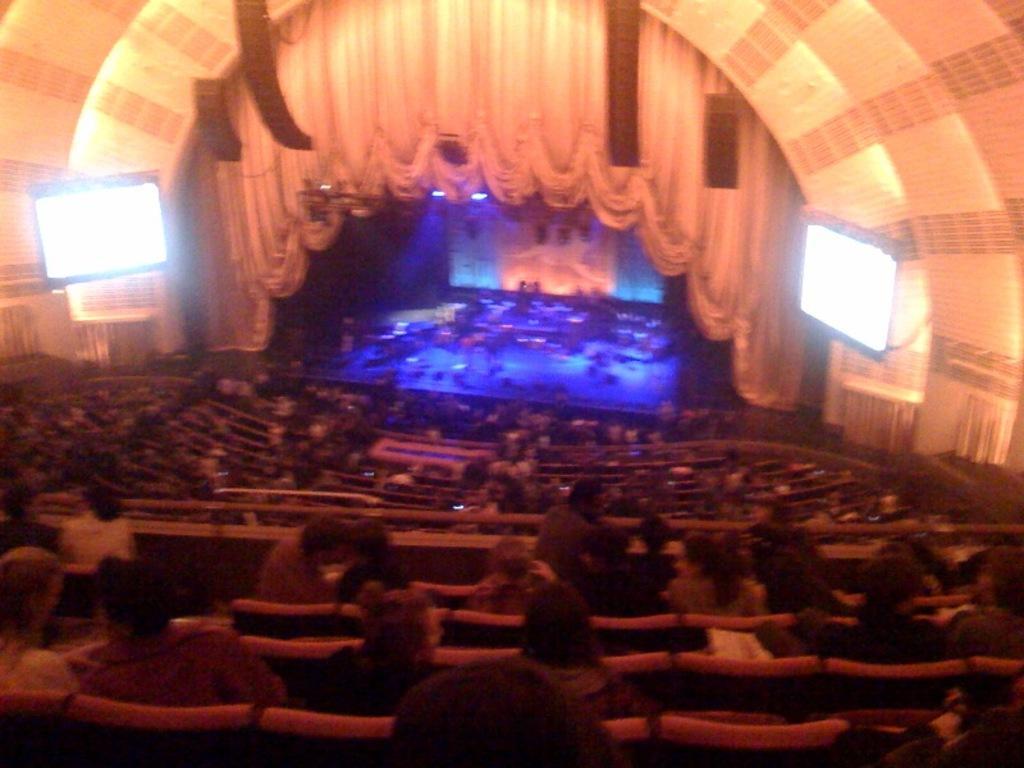Can you describe this image briefly? This picture describes about auditorium, in this we can find few people are seated, in front of them we can see few screens, lights and curtains. 